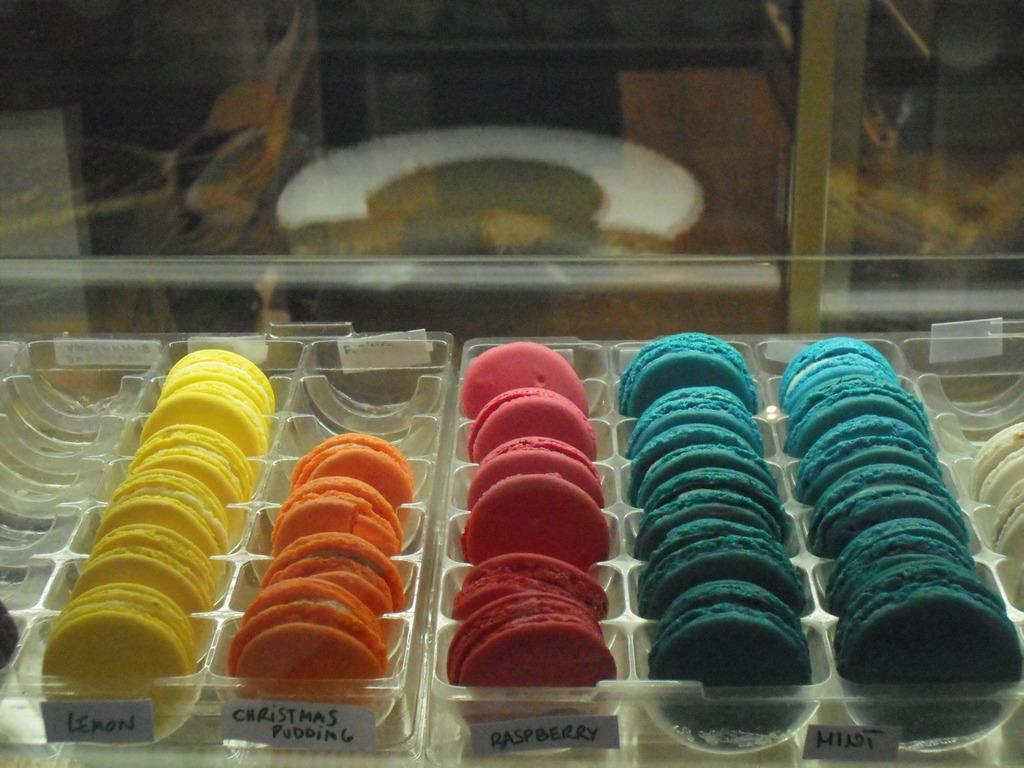<image>
Summarize the visual content of the image. macarons cookie at store display in various flavors 